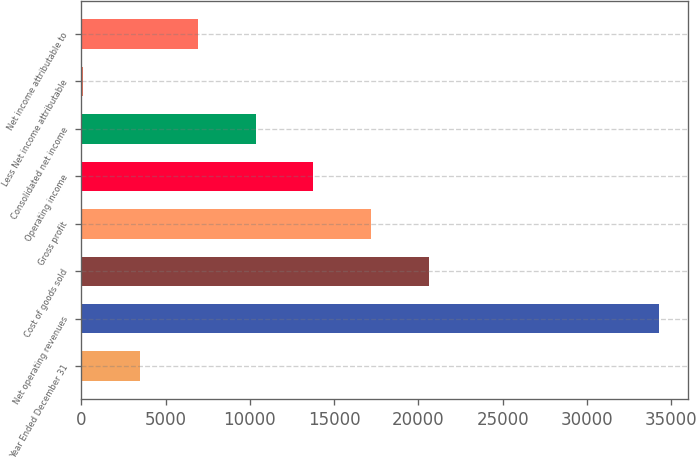Convert chart. <chart><loc_0><loc_0><loc_500><loc_500><bar_chart><fcel>Year Ended December 31<fcel>Net operating revenues<fcel>Cost of goods sold<fcel>Gross profit<fcel>Operating income<fcel>Consolidated net income<fcel>Less Net income attributable<fcel>Net income attributable to<nl><fcel>3499.4<fcel>34292<fcel>20606.4<fcel>17185<fcel>13763.6<fcel>10342.2<fcel>78<fcel>6920.8<nl></chart> 